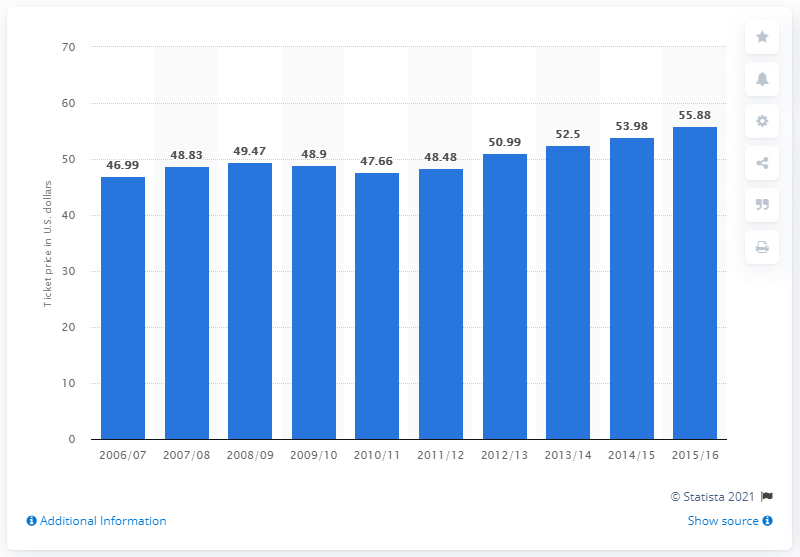Draw attention to some important aspects in this diagram. In the 2006/07 season, the average ticket price was 46.99. 